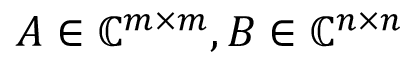Convert formula to latex. <formula><loc_0><loc_0><loc_500><loc_500>A \in \mathbb { C } ^ { m \times m } , B \in \mathbb { C } ^ { n \times n }</formula> 